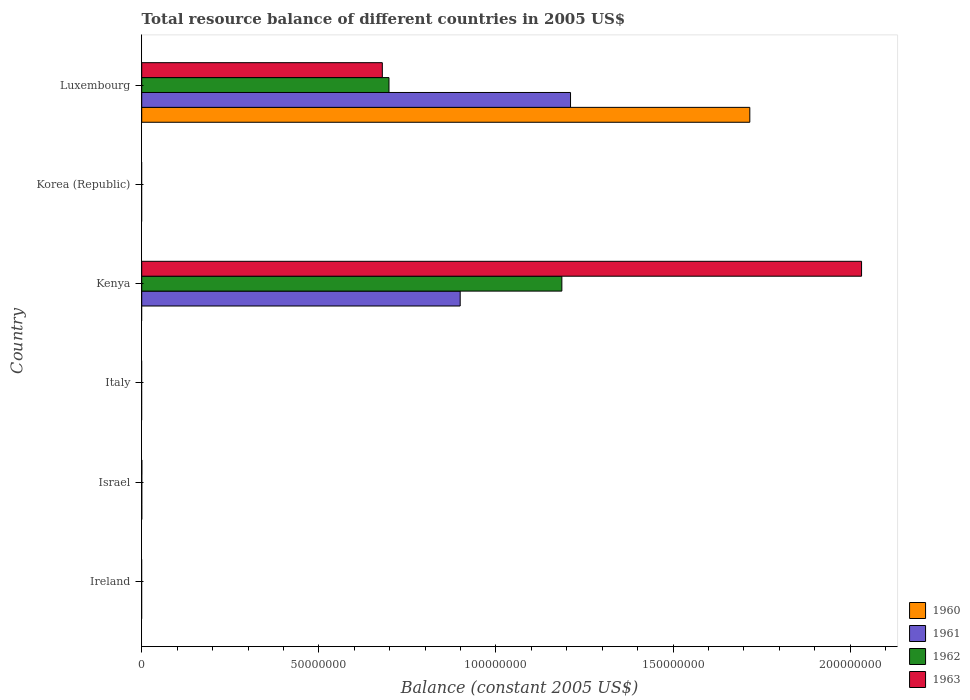Are the number of bars per tick equal to the number of legend labels?
Your response must be concise. No. Are the number of bars on each tick of the Y-axis equal?
Your answer should be compact. No. How many bars are there on the 4th tick from the top?
Your response must be concise. 0. How many bars are there on the 2nd tick from the bottom?
Give a very brief answer. 4. What is the label of the 1st group of bars from the top?
Provide a succinct answer. Luxembourg. In how many cases, is the number of bars for a given country not equal to the number of legend labels?
Provide a short and direct response. 4. Across all countries, what is the maximum total resource balance in 1961?
Your answer should be compact. 1.21e+08. In which country was the total resource balance in 1963 maximum?
Your answer should be very brief. Kenya. What is the total total resource balance in 1961 in the graph?
Keep it short and to the point. 2.11e+08. What is the difference between the total resource balance in 1963 in Israel and that in Luxembourg?
Offer a very short reply. -6.79e+07. What is the difference between the total resource balance in 1960 in Ireland and the total resource balance in 1963 in Kenya?
Provide a succinct answer. -2.03e+08. What is the average total resource balance in 1962 per country?
Provide a succinct answer. 3.14e+07. What is the difference between the total resource balance in 1962 and total resource balance in 1960 in Israel?
Provide a succinct answer. 3900. In how many countries, is the total resource balance in 1963 greater than 180000000 US$?
Provide a short and direct response. 1. What is the ratio of the total resource balance in 1962 in Israel to that in Kenya?
Give a very brief answer. 6.745368250732083e-5. What is the difference between the highest and the second highest total resource balance in 1961?
Keep it short and to the point. 3.11e+07. What is the difference between the highest and the lowest total resource balance in 1963?
Your answer should be very brief. 2.03e+08. How many bars are there?
Your answer should be compact. 11. How many countries are there in the graph?
Give a very brief answer. 6. Does the graph contain any zero values?
Offer a terse response. Yes. How many legend labels are there?
Make the answer very short. 4. What is the title of the graph?
Offer a very short reply. Total resource balance of different countries in 2005 US$. What is the label or title of the X-axis?
Your answer should be compact. Balance (constant 2005 US$). What is the label or title of the Y-axis?
Your answer should be compact. Country. What is the Balance (constant 2005 US$) of 1960 in Ireland?
Offer a terse response. 0. What is the Balance (constant 2005 US$) in 1961 in Ireland?
Offer a very short reply. 0. What is the Balance (constant 2005 US$) in 1962 in Ireland?
Provide a short and direct response. 0. What is the Balance (constant 2005 US$) of 1960 in Israel?
Ensure brevity in your answer.  4100. What is the Balance (constant 2005 US$) of 1961 in Israel?
Offer a very short reply. 2000. What is the Balance (constant 2005 US$) in 1962 in Israel?
Your answer should be very brief. 8000. What is the Balance (constant 2005 US$) of 1963 in Israel?
Your answer should be very brief. 2.37e+04. What is the Balance (constant 2005 US$) in 1962 in Italy?
Make the answer very short. 0. What is the Balance (constant 2005 US$) of 1960 in Kenya?
Offer a terse response. 0. What is the Balance (constant 2005 US$) in 1961 in Kenya?
Keep it short and to the point. 8.99e+07. What is the Balance (constant 2005 US$) in 1962 in Kenya?
Your response must be concise. 1.19e+08. What is the Balance (constant 2005 US$) of 1963 in Kenya?
Offer a very short reply. 2.03e+08. What is the Balance (constant 2005 US$) of 1960 in Korea (Republic)?
Give a very brief answer. 0. What is the Balance (constant 2005 US$) of 1960 in Luxembourg?
Make the answer very short. 1.72e+08. What is the Balance (constant 2005 US$) in 1961 in Luxembourg?
Your response must be concise. 1.21e+08. What is the Balance (constant 2005 US$) in 1962 in Luxembourg?
Provide a short and direct response. 6.98e+07. What is the Balance (constant 2005 US$) in 1963 in Luxembourg?
Your response must be concise. 6.79e+07. Across all countries, what is the maximum Balance (constant 2005 US$) in 1960?
Keep it short and to the point. 1.72e+08. Across all countries, what is the maximum Balance (constant 2005 US$) of 1961?
Offer a terse response. 1.21e+08. Across all countries, what is the maximum Balance (constant 2005 US$) of 1962?
Offer a terse response. 1.19e+08. Across all countries, what is the maximum Balance (constant 2005 US$) of 1963?
Offer a terse response. 2.03e+08. Across all countries, what is the minimum Balance (constant 2005 US$) of 1962?
Make the answer very short. 0. Across all countries, what is the minimum Balance (constant 2005 US$) in 1963?
Provide a short and direct response. 0. What is the total Balance (constant 2005 US$) in 1960 in the graph?
Ensure brevity in your answer.  1.72e+08. What is the total Balance (constant 2005 US$) in 1961 in the graph?
Provide a succinct answer. 2.11e+08. What is the total Balance (constant 2005 US$) in 1962 in the graph?
Provide a succinct answer. 1.88e+08. What is the total Balance (constant 2005 US$) in 1963 in the graph?
Provide a succinct answer. 2.71e+08. What is the difference between the Balance (constant 2005 US$) in 1961 in Israel and that in Kenya?
Make the answer very short. -8.99e+07. What is the difference between the Balance (constant 2005 US$) of 1962 in Israel and that in Kenya?
Give a very brief answer. -1.19e+08. What is the difference between the Balance (constant 2005 US$) of 1963 in Israel and that in Kenya?
Your answer should be compact. -2.03e+08. What is the difference between the Balance (constant 2005 US$) of 1960 in Israel and that in Luxembourg?
Your answer should be very brief. -1.72e+08. What is the difference between the Balance (constant 2005 US$) of 1961 in Israel and that in Luxembourg?
Provide a succinct answer. -1.21e+08. What is the difference between the Balance (constant 2005 US$) in 1962 in Israel and that in Luxembourg?
Your answer should be very brief. -6.98e+07. What is the difference between the Balance (constant 2005 US$) of 1963 in Israel and that in Luxembourg?
Give a very brief answer. -6.79e+07. What is the difference between the Balance (constant 2005 US$) in 1961 in Kenya and that in Luxembourg?
Provide a succinct answer. -3.11e+07. What is the difference between the Balance (constant 2005 US$) in 1962 in Kenya and that in Luxembourg?
Provide a short and direct response. 4.88e+07. What is the difference between the Balance (constant 2005 US$) in 1963 in Kenya and that in Luxembourg?
Ensure brevity in your answer.  1.35e+08. What is the difference between the Balance (constant 2005 US$) of 1960 in Israel and the Balance (constant 2005 US$) of 1961 in Kenya?
Offer a very short reply. -8.99e+07. What is the difference between the Balance (constant 2005 US$) in 1960 in Israel and the Balance (constant 2005 US$) in 1962 in Kenya?
Provide a short and direct response. -1.19e+08. What is the difference between the Balance (constant 2005 US$) of 1960 in Israel and the Balance (constant 2005 US$) of 1963 in Kenya?
Offer a terse response. -2.03e+08. What is the difference between the Balance (constant 2005 US$) of 1961 in Israel and the Balance (constant 2005 US$) of 1962 in Kenya?
Provide a short and direct response. -1.19e+08. What is the difference between the Balance (constant 2005 US$) of 1961 in Israel and the Balance (constant 2005 US$) of 1963 in Kenya?
Keep it short and to the point. -2.03e+08. What is the difference between the Balance (constant 2005 US$) in 1962 in Israel and the Balance (constant 2005 US$) in 1963 in Kenya?
Offer a terse response. -2.03e+08. What is the difference between the Balance (constant 2005 US$) of 1960 in Israel and the Balance (constant 2005 US$) of 1961 in Luxembourg?
Give a very brief answer. -1.21e+08. What is the difference between the Balance (constant 2005 US$) in 1960 in Israel and the Balance (constant 2005 US$) in 1962 in Luxembourg?
Provide a short and direct response. -6.98e+07. What is the difference between the Balance (constant 2005 US$) of 1960 in Israel and the Balance (constant 2005 US$) of 1963 in Luxembourg?
Make the answer very short. -6.79e+07. What is the difference between the Balance (constant 2005 US$) of 1961 in Israel and the Balance (constant 2005 US$) of 1962 in Luxembourg?
Give a very brief answer. -6.98e+07. What is the difference between the Balance (constant 2005 US$) of 1961 in Israel and the Balance (constant 2005 US$) of 1963 in Luxembourg?
Make the answer very short. -6.79e+07. What is the difference between the Balance (constant 2005 US$) in 1962 in Israel and the Balance (constant 2005 US$) in 1963 in Luxembourg?
Your answer should be very brief. -6.79e+07. What is the difference between the Balance (constant 2005 US$) of 1961 in Kenya and the Balance (constant 2005 US$) of 1962 in Luxembourg?
Offer a very short reply. 2.01e+07. What is the difference between the Balance (constant 2005 US$) of 1961 in Kenya and the Balance (constant 2005 US$) of 1963 in Luxembourg?
Keep it short and to the point. 2.20e+07. What is the difference between the Balance (constant 2005 US$) of 1962 in Kenya and the Balance (constant 2005 US$) of 1963 in Luxembourg?
Provide a short and direct response. 5.07e+07. What is the average Balance (constant 2005 US$) of 1960 per country?
Offer a terse response. 2.86e+07. What is the average Balance (constant 2005 US$) in 1961 per country?
Your answer should be very brief. 3.52e+07. What is the average Balance (constant 2005 US$) of 1962 per country?
Offer a very short reply. 3.14e+07. What is the average Balance (constant 2005 US$) in 1963 per country?
Offer a terse response. 4.52e+07. What is the difference between the Balance (constant 2005 US$) of 1960 and Balance (constant 2005 US$) of 1961 in Israel?
Make the answer very short. 2100. What is the difference between the Balance (constant 2005 US$) of 1960 and Balance (constant 2005 US$) of 1962 in Israel?
Keep it short and to the point. -3900. What is the difference between the Balance (constant 2005 US$) of 1960 and Balance (constant 2005 US$) of 1963 in Israel?
Your answer should be very brief. -1.96e+04. What is the difference between the Balance (constant 2005 US$) of 1961 and Balance (constant 2005 US$) of 1962 in Israel?
Your answer should be very brief. -6000. What is the difference between the Balance (constant 2005 US$) in 1961 and Balance (constant 2005 US$) in 1963 in Israel?
Give a very brief answer. -2.17e+04. What is the difference between the Balance (constant 2005 US$) of 1962 and Balance (constant 2005 US$) of 1963 in Israel?
Keep it short and to the point. -1.57e+04. What is the difference between the Balance (constant 2005 US$) in 1961 and Balance (constant 2005 US$) in 1962 in Kenya?
Make the answer very short. -2.87e+07. What is the difference between the Balance (constant 2005 US$) in 1961 and Balance (constant 2005 US$) in 1963 in Kenya?
Make the answer very short. -1.13e+08. What is the difference between the Balance (constant 2005 US$) in 1962 and Balance (constant 2005 US$) in 1963 in Kenya?
Offer a very short reply. -8.46e+07. What is the difference between the Balance (constant 2005 US$) of 1960 and Balance (constant 2005 US$) of 1961 in Luxembourg?
Make the answer very short. 5.06e+07. What is the difference between the Balance (constant 2005 US$) of 1960 and Balance (constant 2005 US$) of 1962 in Luxembourg?
Provide a short and direct response. 1.02e+08. What is the difference between the Balance (constant 2005 US$) of 1960 and Balance (constant 2005 US$) of 1963 in Luxembourg?
Give a very brief answer. 1.04e+08. What is the difference between the Balance (constant 2005 US$) of 1961 and Balance (constant 2005 US$) of 1962 in Luxembourg?
Keep it short and to the point. 5.12e+07. What is the difference between the Balance (constant 2005 US$) in 1961 and Balance (constant 2005 US$) in 1963 in Luxembourg?
Your answer should be very brief. 5.31e+07. What is the difference between the Balance (constant 2005 US$) of 1962 and Balance (constant 2005 US$) of 1963 in Luxembourg?
Make the answer very short. 1.88e+06. What is the ratio of the Balance (constant 2005 US$) in 1961 in Israel to that in Kenya?
Your answer should be compact. 0. What is the ratio of the Balance (constant 2005 US$) of 1963 in Israel to that in Kenya?
Provide a short and direct response. 0. What is the ratio of the Balance (constant 2005 US$) in 1962 in Israel to that in Luxembourg?
Provide a succinct answer. 0. What is the ratio of the Balance (constant 2005 US$) in 1963 in Israel to that in Luxembourg?
Your answer should be compact. 0. What is the ratio of the Balance (constant 2005 US$) in 1961 in Kenya to that in Luxembourg?
Offer a terse response. 0.74. What is the ratio of the Balance (constant 2005 US$) of 1962 in Kenya to that in Luxembourg?
Keep it short and to the point. 1.7. What is the ratio of the Balance (constant 2005 US$) in 1963 in Kenya to that in Luxembourg?
Ensure brevity in your answer.  2.99. What is the difference between the highest and the second highest Balance (constant 2005 US$) of 1961?
Provide a short and direct response. 3.11e+07. What is the difference between the highest and the second highest Balance (constant 2005 US$) of 1962?
Ensure brevity in your answer.  4.88e+07. What is the difference between the highest and the second highest Balance (constant 2005 US$) in 1963?
Provide a succinct answer. 1.35e+08. What is the difference between the highest and the lowest Balance (constant 2005 US$) in 1960?
Offer a very short reply. 1.72e+08. What is the difference between the highest and the lowest Balance (constant 2005 US$) in 1961?
Make the answer very short. 1.21e+08. What is the difference between the highest and the lowest Balance (constant 2005 US$) in 1962?
Make the answer very short. 1.19e+08. What is the difference between the highest and the lowest Balance (constant 2005 US$) in 1963?
Give a very brief answer. 2.03e+08. 